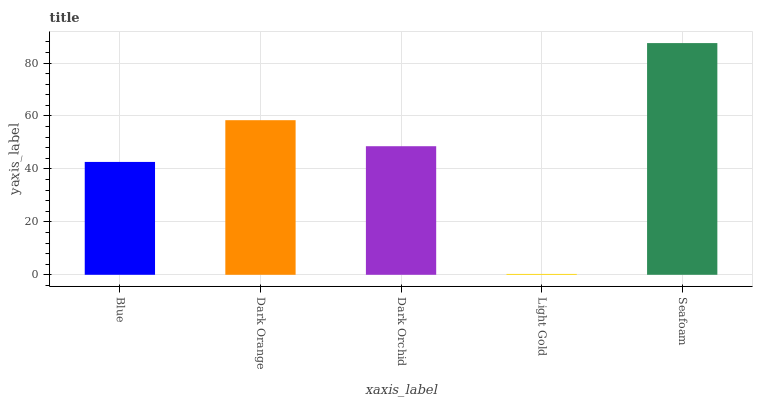Is Light Gold the minimum?
Answer yes or no. Yes. Is Seafoam the maximum?
Answer yes or no. Yes. Is Dark Orange the minimum?
Answer yes or no. No. Is Dark Orange the maximum?
Answer yes or no. No. Is Dark Orange greater than Blue?
Answer yes or no. Yes. Is Blue less than Dark Orange?
Answer yes or no. Yes. Is Blue greater than Dark Orange?
Answer yes or no. No. Is Dark Orange less than Blue?
Answer yes or no. No. Is Dark Orchid the high median?
Answer yes or no. Yes. Is Dark Orchid the low median?
Answer yes or no. Yes. Is Light Gold the high median?
Answer yes or no. No. Is Blue the low median?
Answer yes or no. No. 